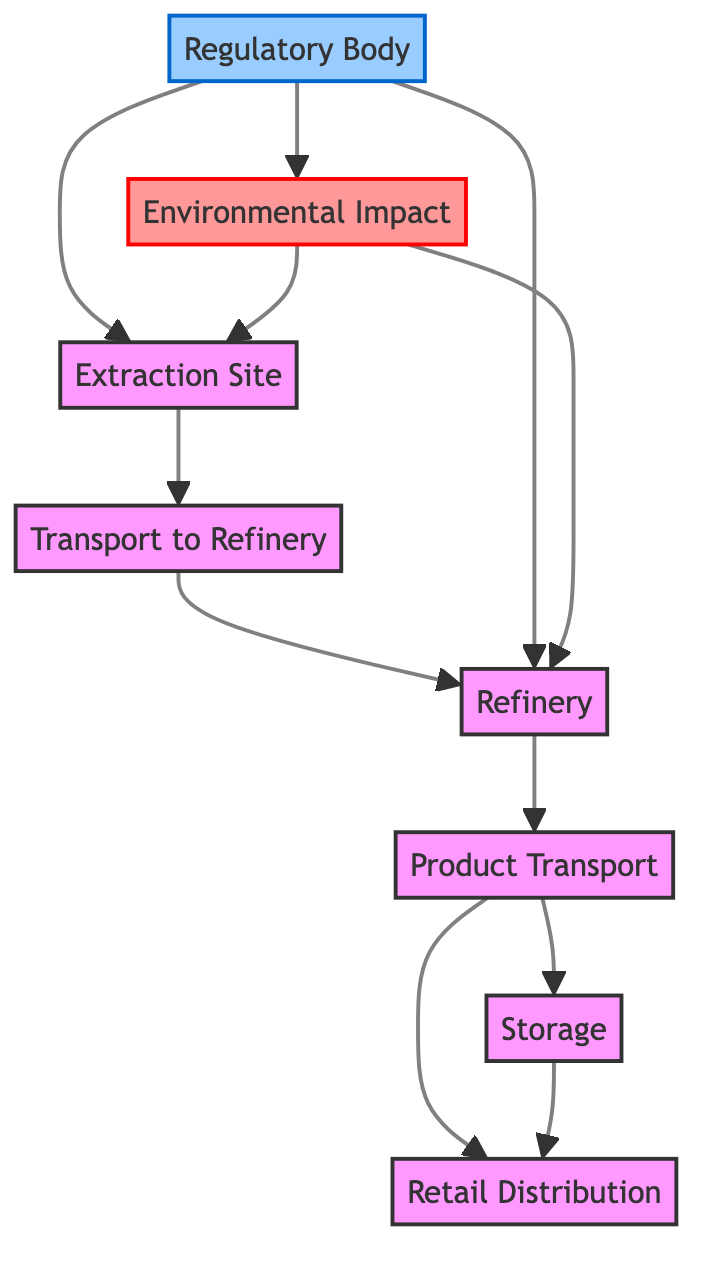What is the starting point of the supply chain network? The starting point in the diagram is the "Extraction Site". This can be determined by looking for the node that has outgoing connections but no incoming connections from a prior stage.
Answer: Extraction Site How many nodes are present in the diagram? Counting the distinct nodes involved in the diagram, we can identify eight unique nodes, which includes Extraction Site, Transport to Refinery, Refinery, Product Transport, Storage, Retail Distribution, Regulatory Body, and Environmental Impact.
Answer: 8 Which node receives crude oil after transport to refinery? The node that directly receives crude oil after "Transport to Refinery" is the "Refinery". This is evident since "Transport to Refinery" has a direct edge pointing to "Refinery".
Answer: Refinery What type of transport can be used from the "Transport to Refinery" node? The diagram indicates that the types of transport methods that connect to "Transport to Refinery" include pipelines and tankers, as stated in the description associated with the edge leading to the "Refinery".
Answer: Pipelines, Tankers Which nodes are connected to the "Regulatory Body"? The "Regulatory Body" connects to three nodes: "Extraction Site", "Refinery", and "Environmental Impact". Each connection represents the oversight it provides to those parts of the supply chain.
Answer: Extraction Site, Refinery, Environmental Impact What impacts the extraction practices according to the diagram? The diagram shows that "Environmental Impact" influences the practices at the "Extraction Site". This is indicated by the directed edge from "Environmental Impact" to "Extraction Site".
Answer: Environmental Impact How are refined products distributed to the retail distribution points? Refined products are distributed to "Retail Distribution" via two paths: one from "Product Transport" directly to "Retail Distribution" and another from "Storage" to "Retail Distribution". Both paths illustrate the flow of refined products to end points.
Answer: Product Transport, Storage What role does the "Environmental Impact" node serve in this supply chain? The "Environmental Impact" node acts to influence both the "Extraction Site" and "Refinery" nodes, as suggested by the edges leading from "Environmental Impact" to these sites, indicating that environmental considerations are factored into operations.
Answer: Influences extraction and refining practices How many edges connect the "Storage" node to other nodes? The "Storage" node has two edges connected to it, one leading to "Product Transport" and another leading to "Retail Distribution", indicating its role in the distribution of products.
Answer: 2 